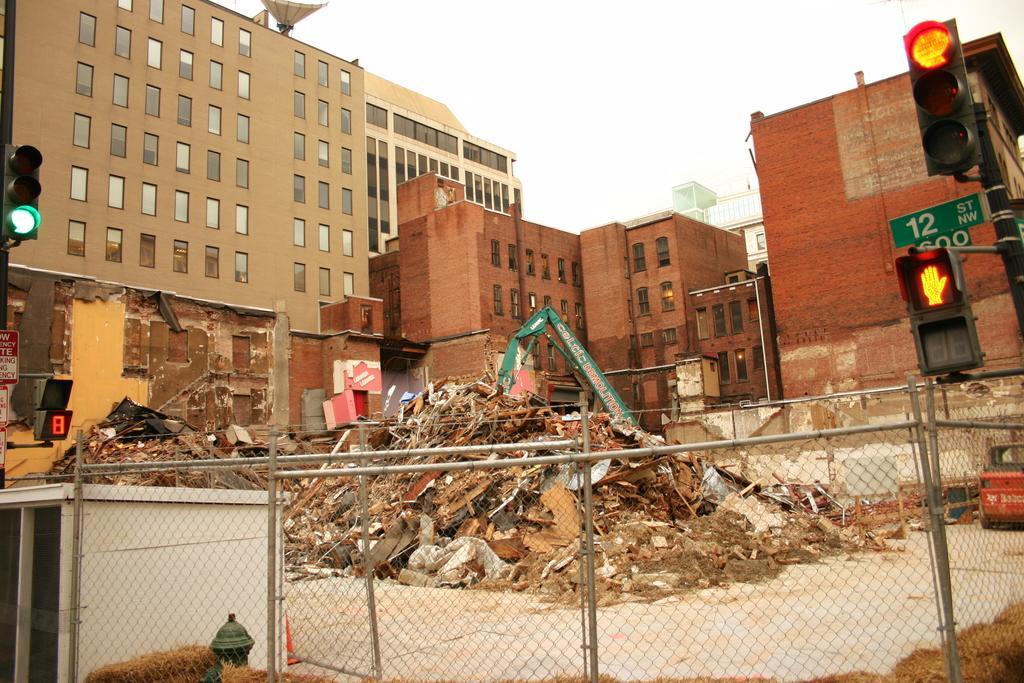Please provide a concise description of this image. In this image, I can see the buildings with windows. At the bottom of the image, I can see a fence, fire hydrant and a shed. On the left and right side of the image, there are traffic lights. I can see the waste materials and a crane. In the background, I can see the sky. 